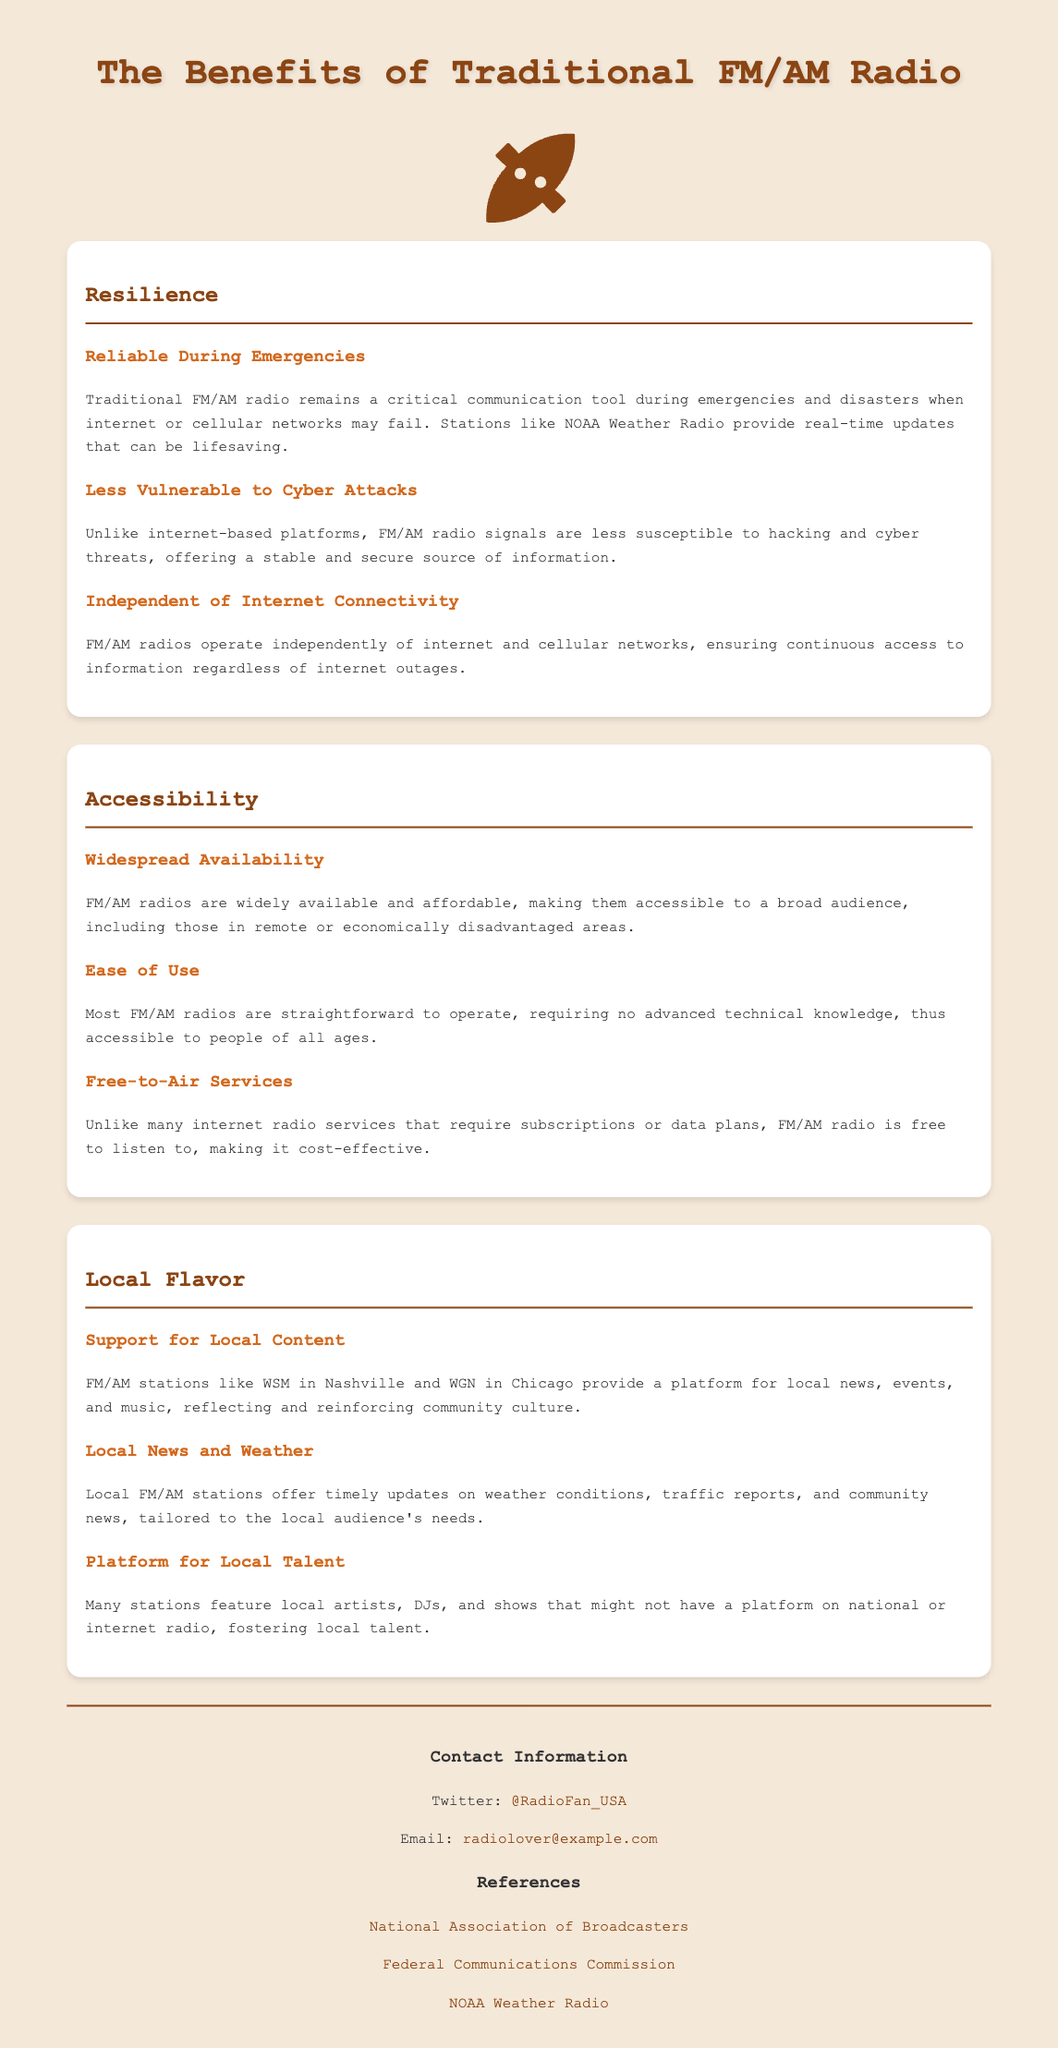What is the title of the infographic? The title is prominently displayed at the top of the infographic, highlighting the focus on traditional radio.
Answer: The Benefits of Traditional FM/AM Radio Which section discusses emergency communication? The section titled 'Resilience' covers critical communication during emergencies.
Answer: Resilience What is one feature of FM/AM radios regarding cyber threats? The information under 'Less Vulnerable to Cyber Attacks' indicates that FM/AM radios are not susceptible to hacking.
Answer: Less Vulnerable to Cyber Attacks What makes FM/AM radio accessible to economically disadvantaged areas? The 'Widespread Availability' detail points out the affordability and operation of FM/AM radios.
Answer: Widespread Availability Which radio station is mentioned as an example of local content support? The detail under 'Support for Local Content' provides specific station names that reflect community culture.
Answer: WSM in Nashville What is a key advantage of FM/AM radio during internet outages? The section highlights that FM/AM radios operate independently of internet connectivity.
Answer: Independent of Internet Connectivity How are FM/AM radio services financially structured? The detail points out that these services are free to listen to, making them cost-effective compared to some internet options.
Answer: Free-to-Air Services What role does FM/AM radio play for local talent? The section highlights that many stations foster local talent by featuring artists and shows.
Answer: Platform for Local Talent Which type of updates do local FM/AM stations provide? The 'Local News and Weather' detail indicates they offer timely updates tailored to local needs.
Answer: Local News and Weather 